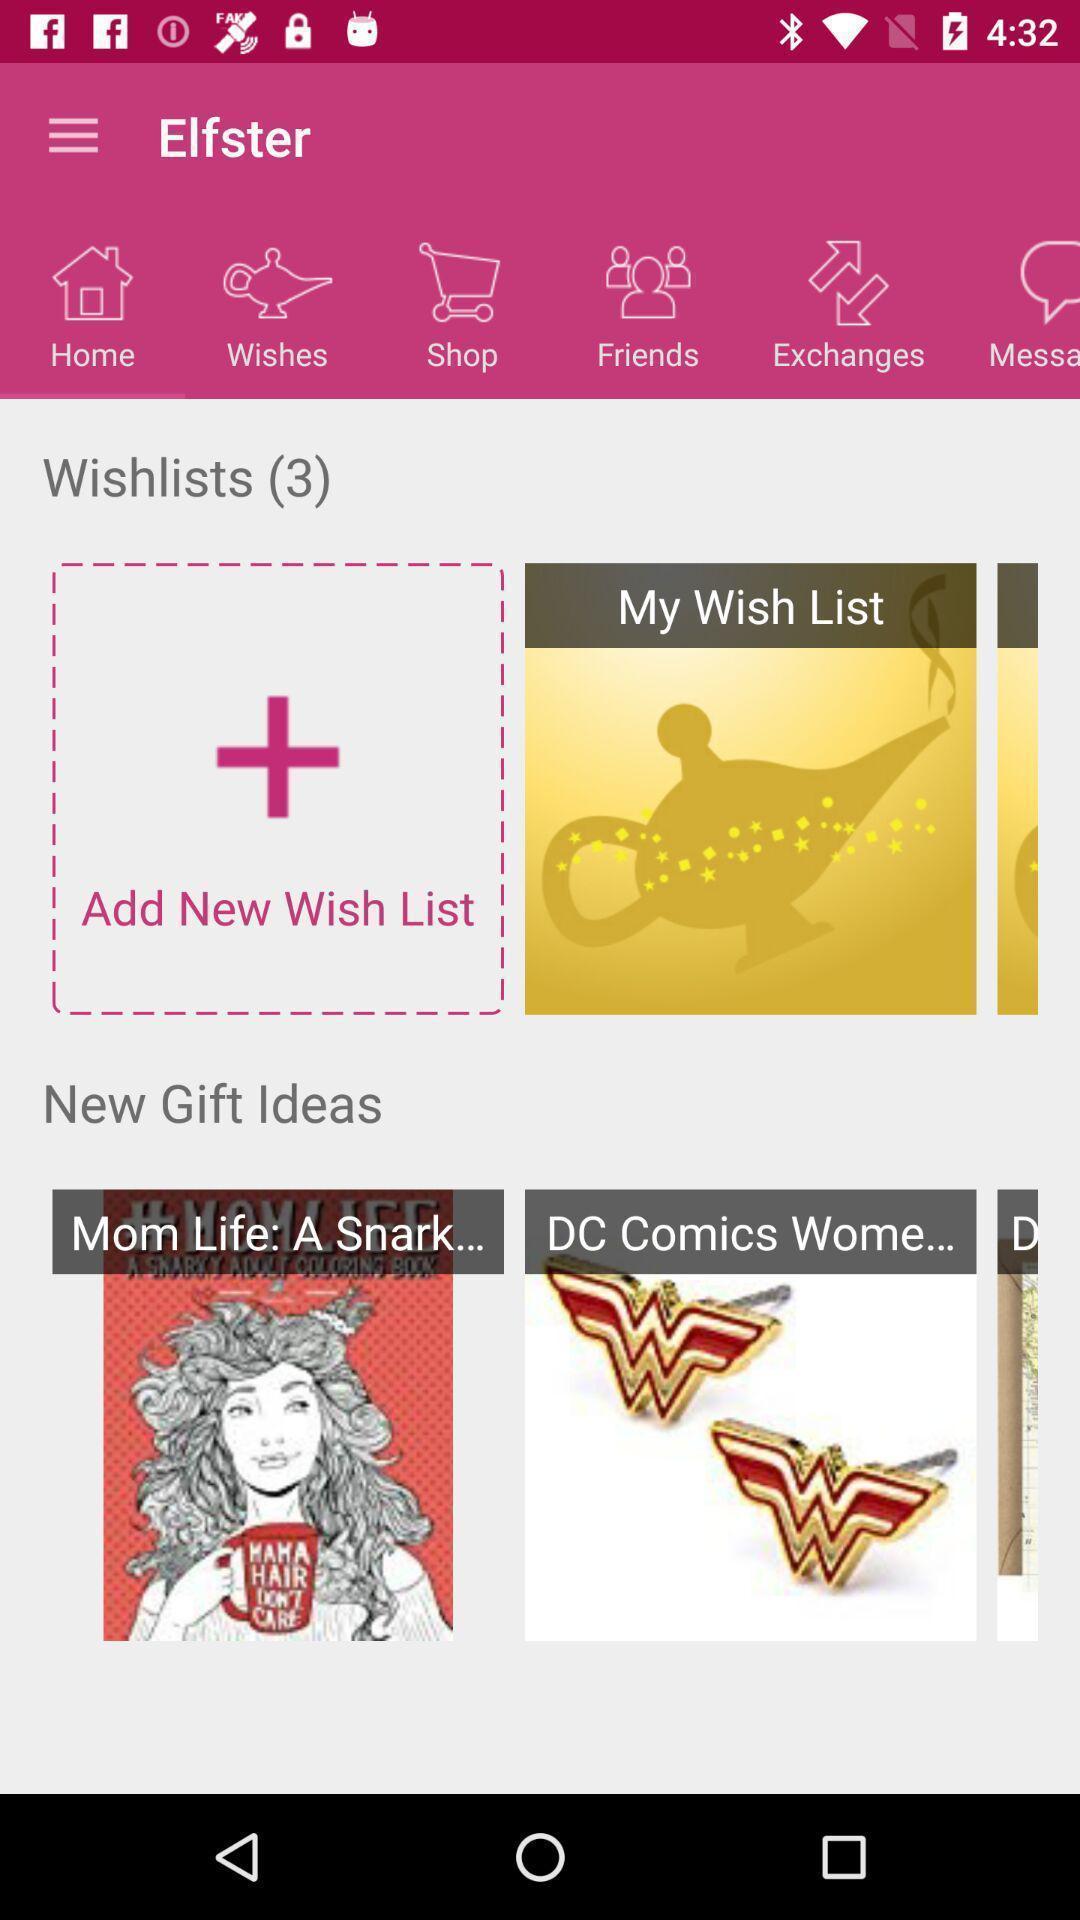Tell me about the visual elements in this screen capture. Page displaying wishlists. 